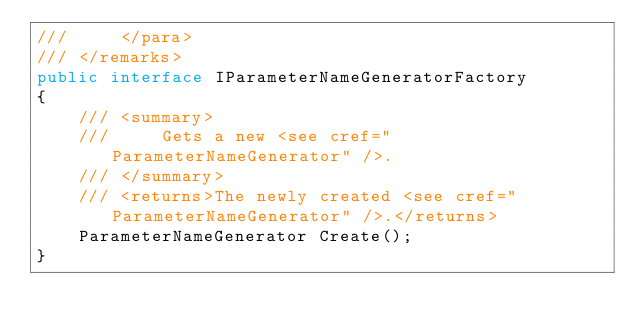Convert code to text. <code><loc_0><loc_0><loc_500><loc_500><_C#_>///     </para>
/// </remarks>
public interface IParameterNameGeneratorFactory
{
    /// <summary>
    ///     Gets a new <see cref="ParameterNameGenerator" />.
    /// </summary>
    /// <returns>The newly created <see cref="ParameterNameGenerator" />.</returns>
    ParameterNameGenerator Create();
}
</code> 